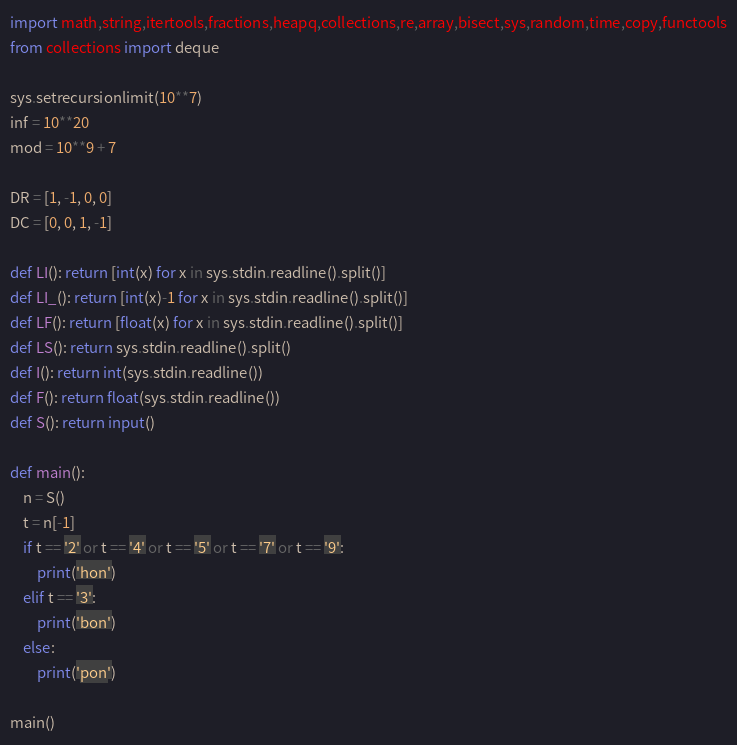<code> <loc_0><loc_0><loc_500><loc_500><_Python_>import math,string,itertools,fractions,heapq,collections,re,array,bisect,sys,random,time,copy,functools
from collections import deque

sys.setrecursionlimit(10**7)
inf = 10**20
mod = 10**9 + 7

DR = [1, -1, 0, 0]
DC = [0, 0, 1, -1]

def LI(): return [int(x) for x in sys.stdin.readline().split()]
def LI_(): return [int(x)-1 for x in sys.stdin.readline().split()]
def LF(): return [float(x) for x in sys.stdin.readline().split()]
def LS(): return sys.stdin.readline().split()
def I(): return int(sys.stdin.readline())
def F(): return float(sys.stdin.readline())
def S(): return input()
     
def main():
    n = S()
    t = n[-1]
    if t == '2' or t == '4' or t == '5' or t == '7' or t == '9':
        print('hon')
    elif t == '3':
        print('bon')
    else:
        print('pon')

main()

</code> 